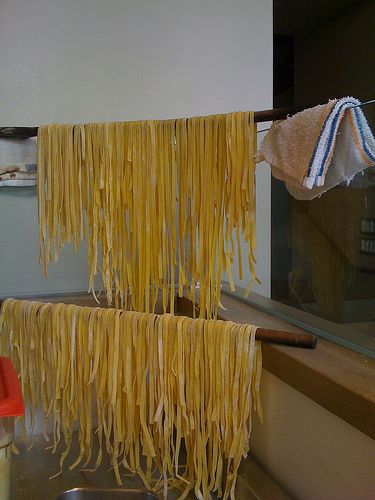<image>
Can you confirm if the wash cloth is behind the pasta? No. The wash cloth is not behind the pasta. From this viewpoint, the wash cloth appears to be positioned elsewhere in the scene. Is there a noodle behind the stick? No. The noodle is not behind the stick. From this viewpoint, the noodle appears to be positioned elsewhere in the scene. 